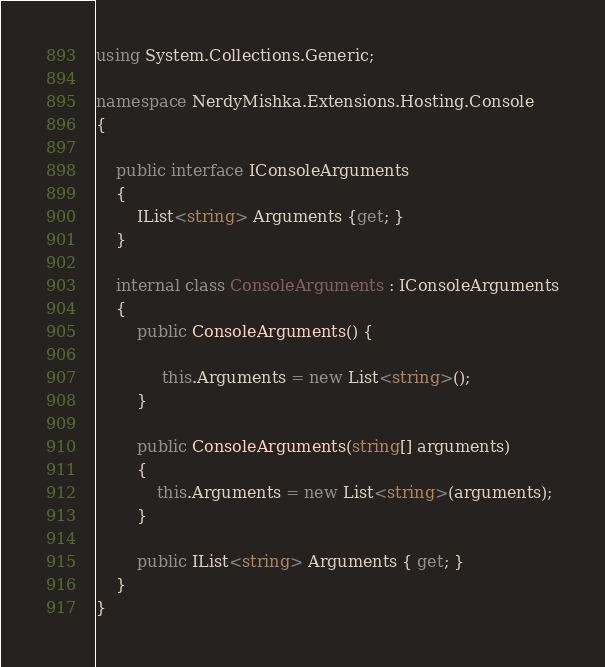Convert code to text. <code><loc_0><loc_0><loc_500><loc_500><_C#_>using System.Collections.Generic;

namespace NerdyMishka.Extensions.Hosting.Console
{

    public interface IConsoleArguments
    {
        IList<string> Arguments {get; }
    }

    internal class ConsoleArguments : IConsoleArguments
    {
        public ConsoleArguments() {

             this.Arguments = new List<string>();
        }

        public ConsoleArguments(string[] arguments)
        {
            this.Arguments = new List<string>(arguments);
        }

        public IList<string> Arguments { get; }
    }
}</code> 